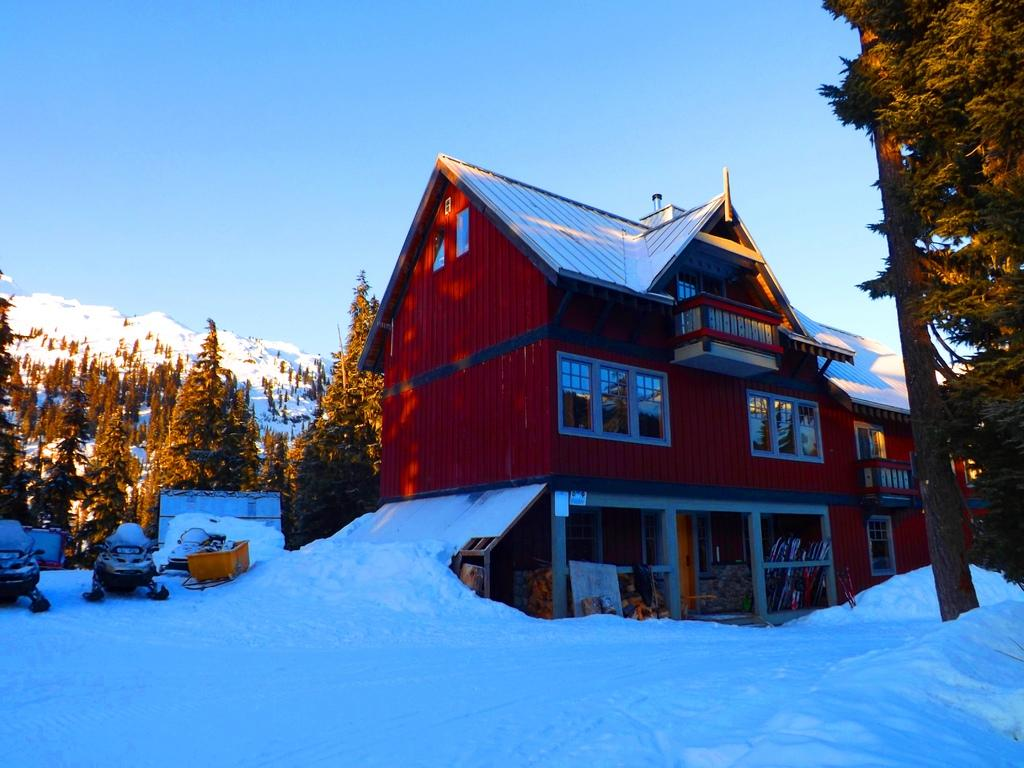What type of vegetation can be seen in the image? There are trees in the image. What type of structures are present in the image? There are houses in the image. What is covering the surface in the image? The surface has snow. What type of vehicles are parked beside a house in the image? Snow bikes are parked beside a house in the image. What can be seen in the background of the image? There are snowy mountains in the background of the image. What word is written on the snow beside the snow bikes? There is no word written on the snow beside the snow bikes in the image. What type of journey can be seen in the image? There is no journey depicted in the image; it shows a snowy landscape with houses, trees, and snow bikes. 